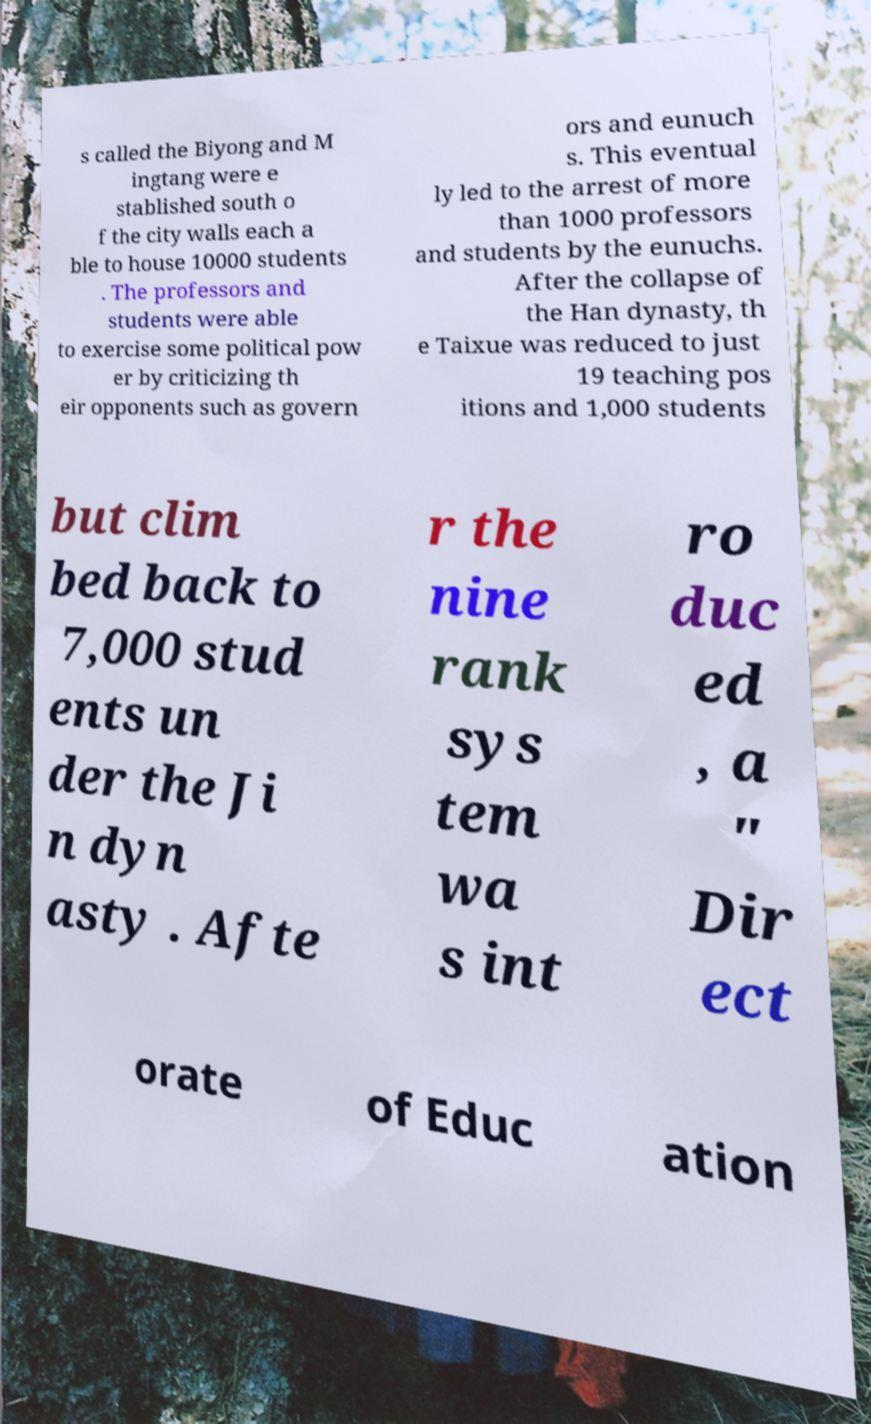Please read and relay the text visible in this image. What does it say? s called the Biyong and M ingtang were e stablished south o f the city walls each a ble to house 10000 students . The professors and students were able to exercise some political pow er by criticizing th eir opponents such as govern ors and eunuch s. This eventual ly led to the arrest of more than 1000 professors and students by the eunuchs. After the collapse of the Han dynasty, th e Taixue was reduced to just 19 teaching pos itions and 1,000 students but clim bed back to 7,000 stud ents un der the Ji n dyn asty . Afte r the nine rank sys tem wa s int ro duc ed , a " Dir ect orate of Educ ation 